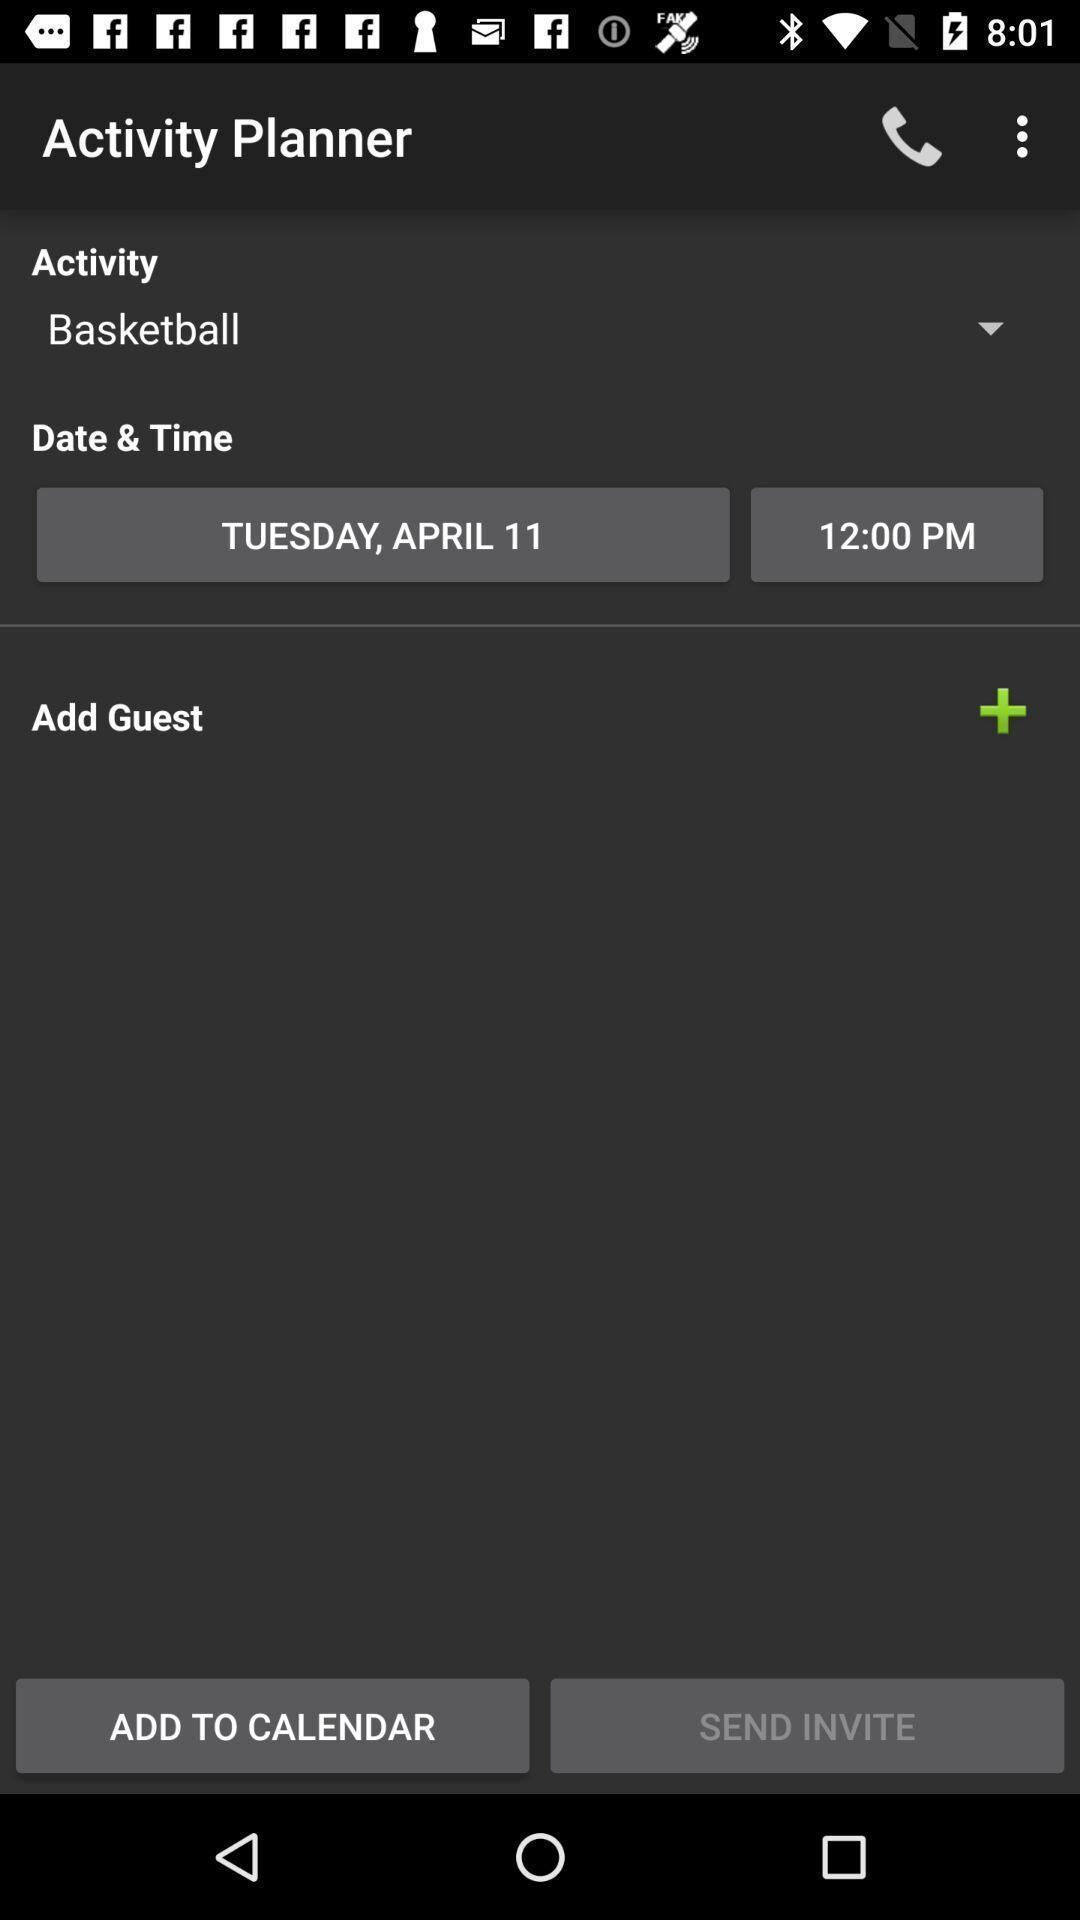Provide a textual representation of this image. Screen showing activity planner. 